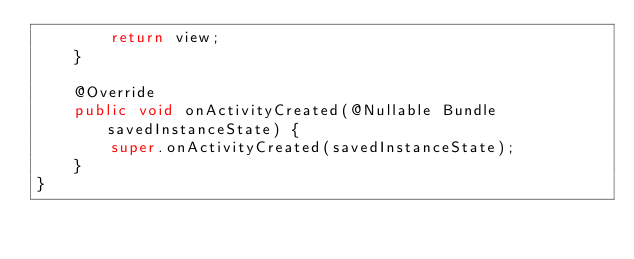<code> <loc_0><loc_0><loc_500><loc_500><_Java_>        return view;
    }

    @Override
    public void onActivityCreated(@Nullable Bundle savedInstanceState) {
        super.onActivityCreated(savedInstanceState);
    }
}
</code> 